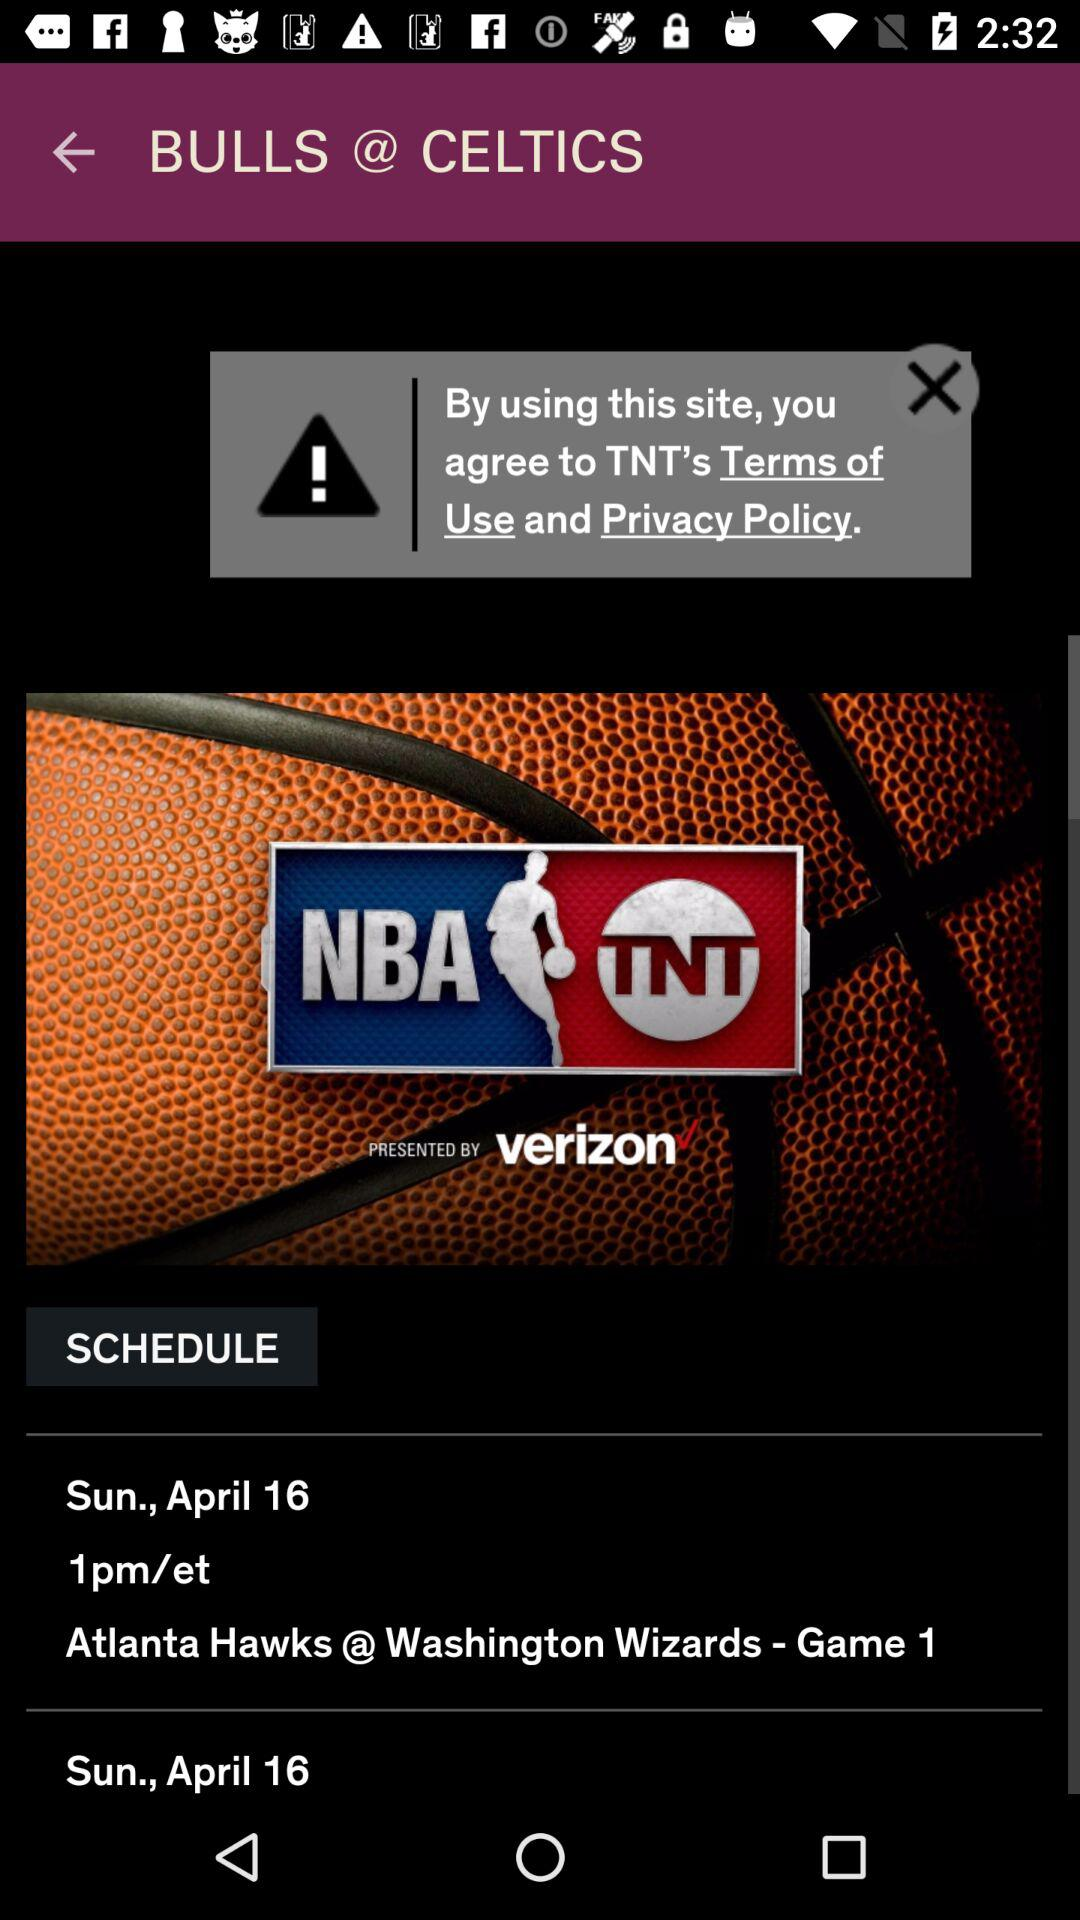What is the scheduled date? The date is Sunday, April 16. 